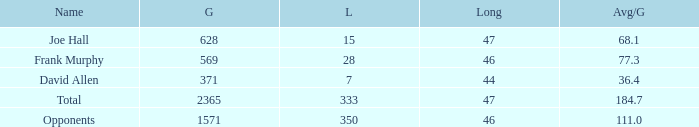How much Avg/G has a Gain smaller than 1571, and a Long smaller than 46? 1.0. Would you be able to parse every entry in this table? {'header': ['Name', 'G', 'L', 'Long', 'Avg/G'], 'rows': [['Joe Hall', '628', '15', '47', '68.1'], ['Frank Murphy', '569', '28', '46', '77.3'], ['David Allen', '371', '7', '44', '36.4'], ['Total', '2365', '333', '47', '184.7'], ['Opponents', '1571', '350', '46', '111.0']]} 